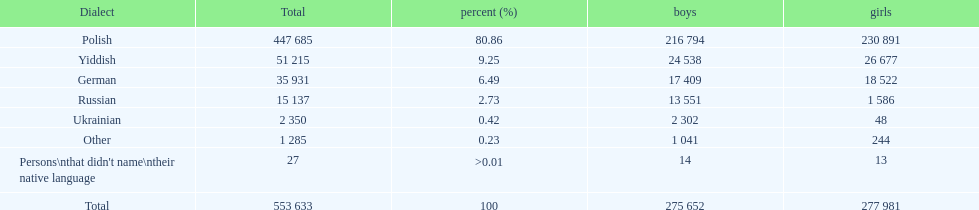Which language did only .42% of people in the imperial census of 1897 speak in the p&#322;ock governorate? Ukrainian. 